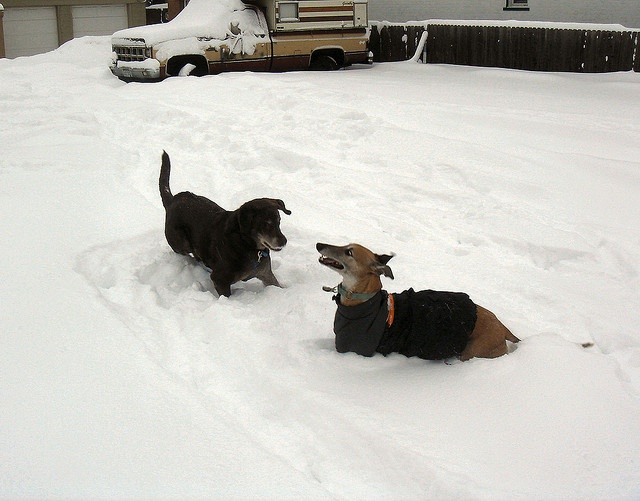Describe the objects in this image and their specific colors. I can see truck in black, lightgray, darkgray, and gray tones, dog in black, maroon, and lightgray tones, and dog in black and gray tones in this image. 